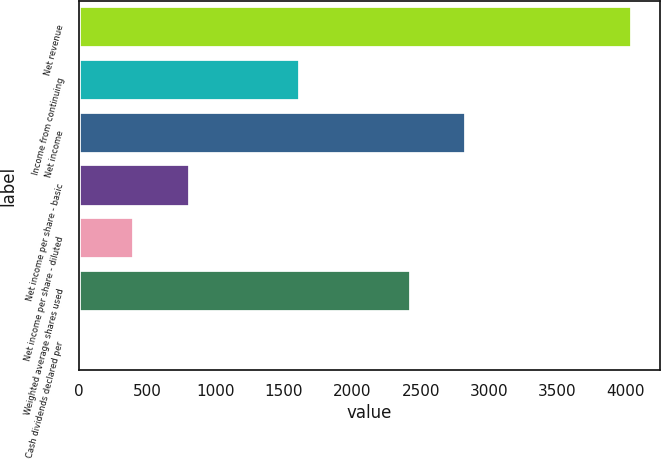Convert chart. <chart><loc_0><loc_0><loc_500><loc_500><bar_chart><fcel>Net revenue<fcel>Income from continuing<fcel>Net income<fcel>Net income per share - basic<fcel>Net income per share - diluted<fcel>Weighted average shares used<fcel>Cash dividends declared per<nl><fcel>4048<fcel>1619.53<fcel>2833.78<fcel>810.03<fcel>405.28<fcel>2429.03<fcel>0.53<nl></chart> 